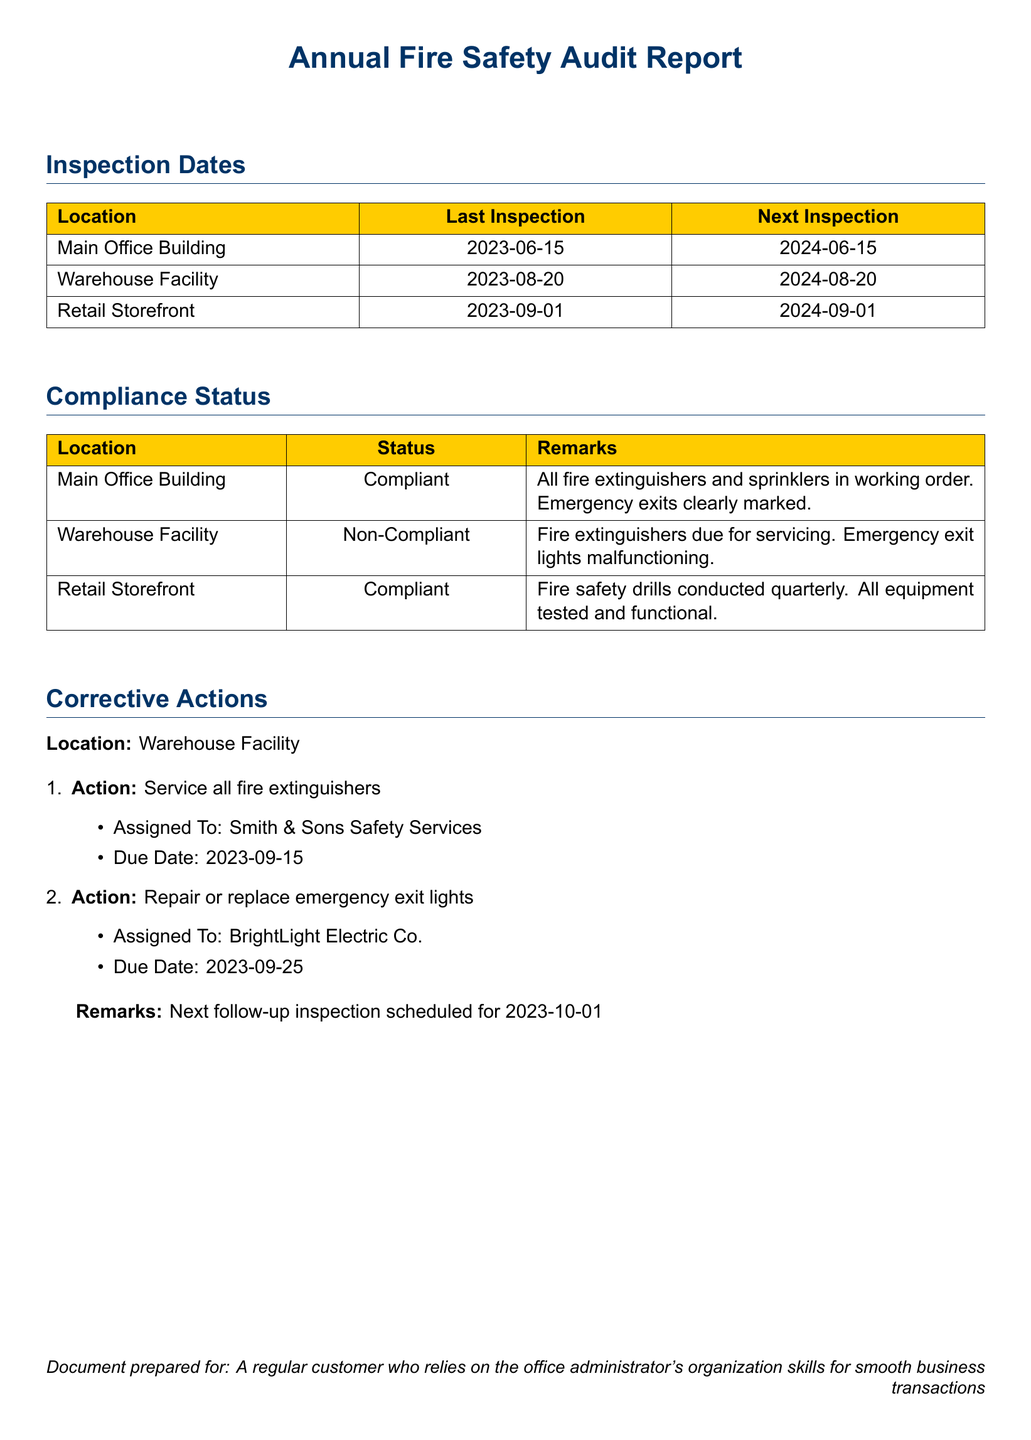what is the last inspection date for the Main Office Building? The last inspection date for the Main Office Building is listed in the Inspection Dates section.
Answer: 2023-06-15 what is the compliance status of the Warehouse Facility? The compliance status of the Warehouse Facility is detailed in the Compliance Status section.
Answer: Non-Compliant when is the next inspection for the Retail Storefront? The next inspection date for the Retail Storefront is available in the Inspection Dates section.
Answer: 2024-09-01 who is assigned to service the fire extinguishers at the Warehouse Facility? The assignment details for servicing fire extinguishers are provided under Corrective Actions.
Answer: Smith & Sons Safety Services what corrective action is scheduled for September 25, 2023? The corrective actions with their due dates are listed in the Corrective Actions section.
Answer: Repair or replace emergency exit lights how many fire safety drills are conducted at the Retail Storefront? Information on fire safety drills at the Retail Storefront is included in the Compliance Status section.
Answer: quarterly what is the due date for the next follow-up inspection? The next follow-up inspection date is mentioned in the Corrective Actions section.
Answer: 2023-10-01 how many locations were inspected in total? The total number of inspected locations can be counted from the Inspection Dates section.
Answer: 3 what are the remarks for the Main Office Building? Remarks for the Main Office Building can be found in the Compliance Status section.
Answer: All fire extinguishers and sprinklers in working order. Emergency exits clearly marked 